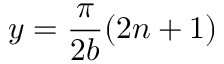<formula> <loc_0><loc_0><loc_500><loc_500>y = \frac { \pi } { 2 b } ( 2 n + 1 )</formula> 